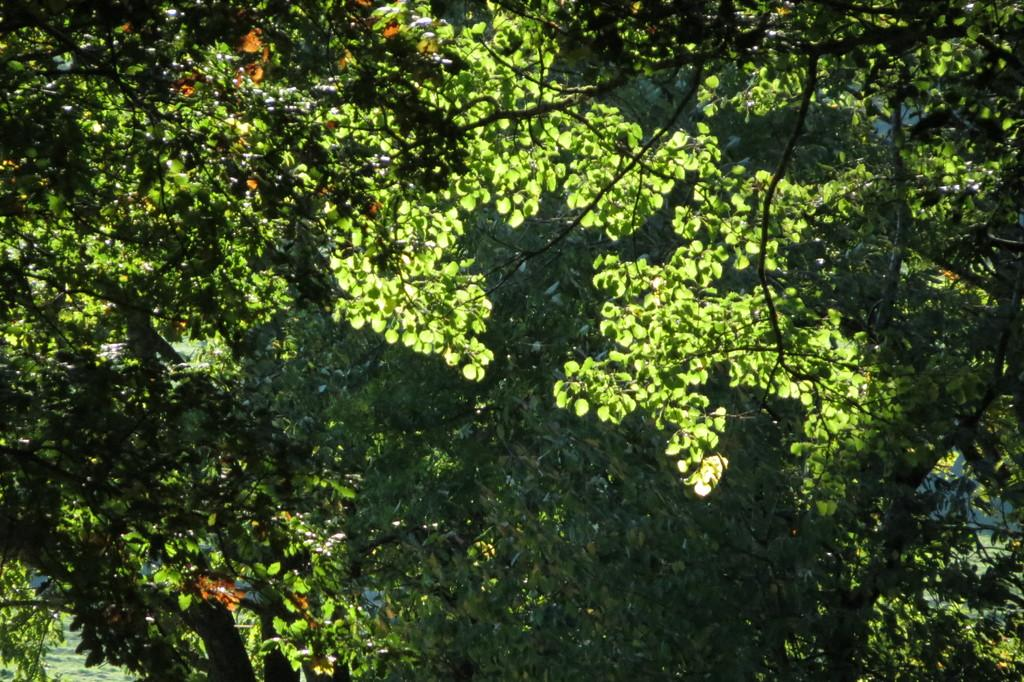What type of natural vegetation is visible in the image? The image contains trees. What type of heat source can be seen in the image? There is no heat source present in the image; it features trees. What type of container is visible in the image? There is no container present in the image. What type of vehicles are visible in the image? There are no vehicles present in the image. 